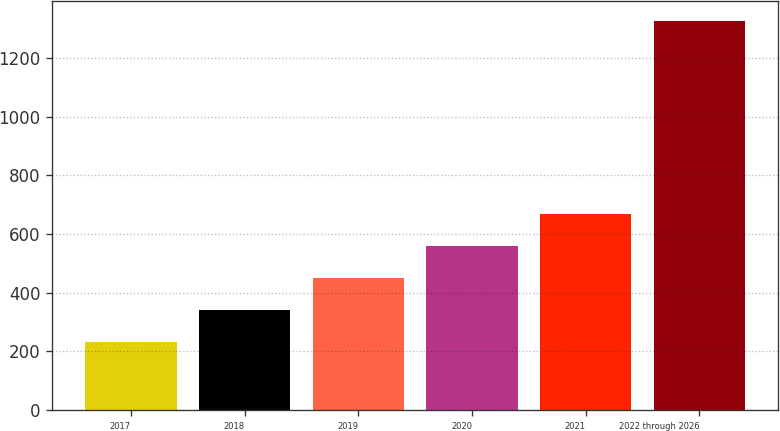Convert chart. <chart><loc_0><loc_0><loc_500><loc_500><bar_chart><fcel>2017<fcel>2018<fcel>2019<fcel>2020<fcel>2021<fcel>2022 through 2026<nl><fcel>230<fcel>339.7<fcel>449.4<fcel>559.1<fcel>668.8<fcel>1327<nl></chart> 